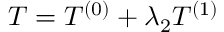Convert formula to latex. <formula><loc_0><loc_0><loc_500><loc_500>\begin{array} { r } { T = T ^ { ( 0 ) } + \lambda _ { 2 } T ^ { ( 1 ) } } \end{array}</formula> 